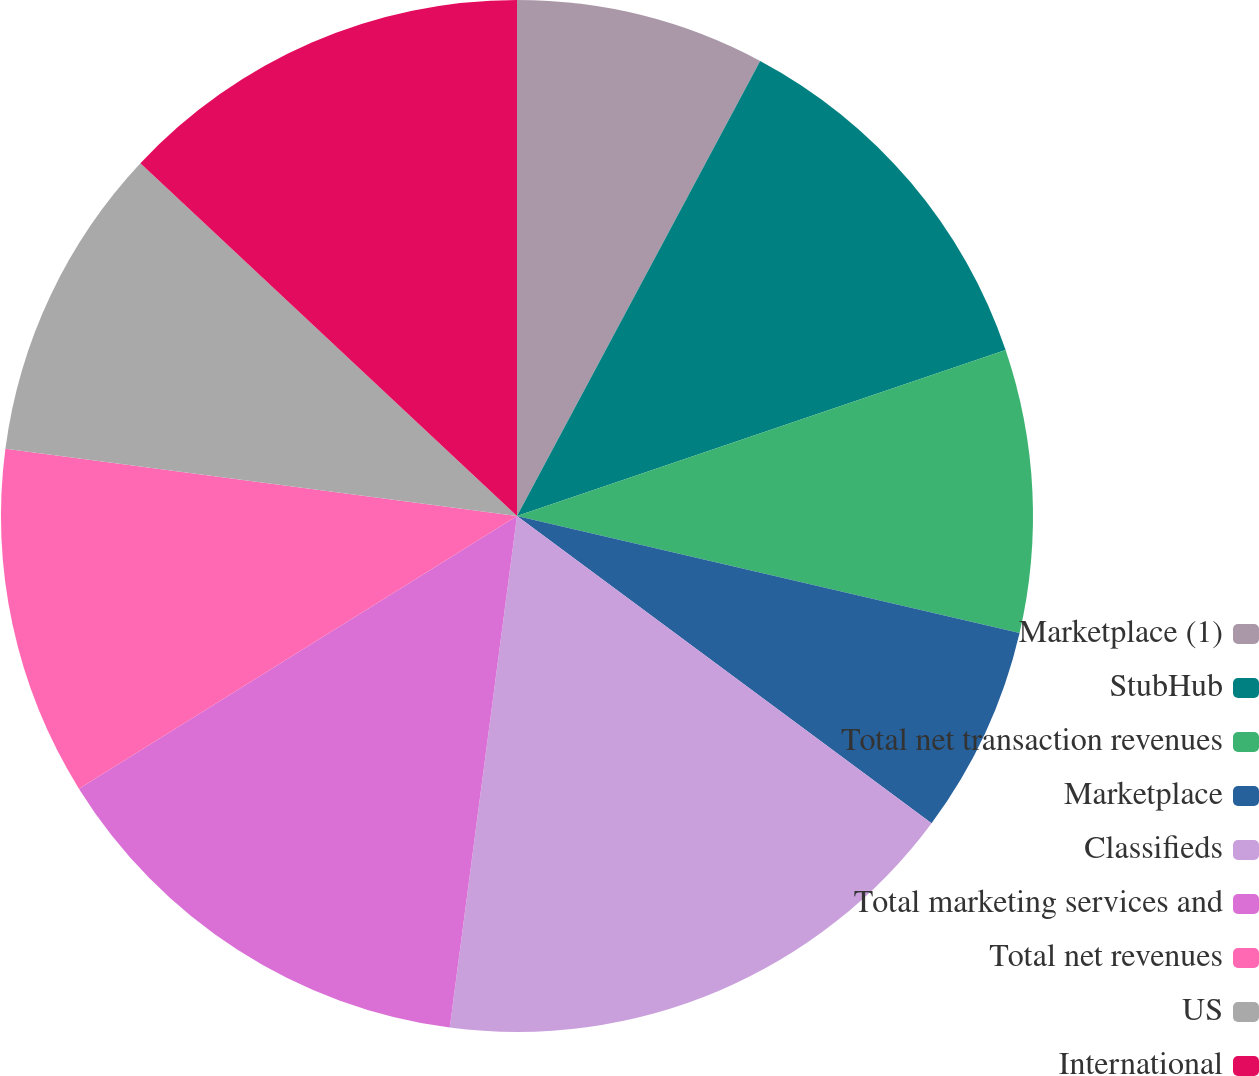Convert chart to OTSL. <chart><loc_0><loc_0><loc_500><loc_500><pie_chart><fcel>Marketplace (1)<fcel>StubHub<fcel>Total net transaction revenues<fcel>Marketplace<fcel>Classifieds<fcel>Total marketing services and<fcel>Total net revenues<fcel>US<fcel>International<nl><fcel>7.81%<fcel>11.98%<fcel>8.85%<fcel>6.51%<fcel>16.93%<fcel>14.06%<fcel>10.94%<fcel>9.9%<fcel>13.02%<nl></chart> 